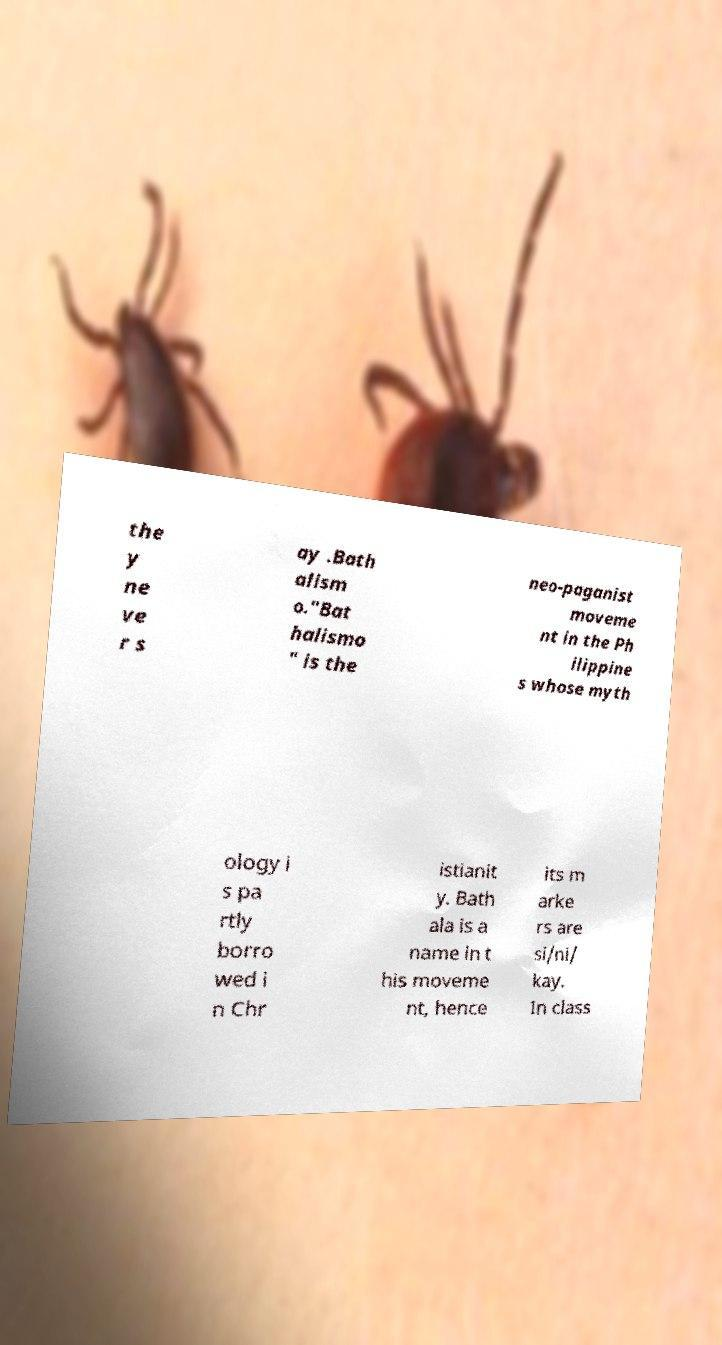For documentation purposes, I need the text within this image transcribed. Could you provide that? the y ne ve r s ay .Bath alism o."Bat halismo " is the neo-paganist moveme nt in the Ph ilippine s whose myth ology i s pa rtly borro wed i n Chr istianit y. Bath ala is a name in t his moveme nt, hence its m arke rs are si/ni/ kay. In class 